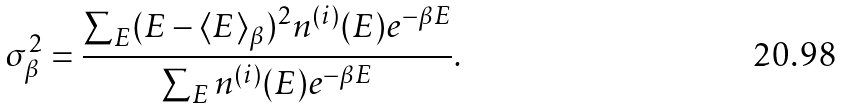<formula> <loc_0><loc_0><loc_500><loc_500>\sigma _ { \beta } ^ { 2 } = \frac { \sum _ { E } ( E - \langle E \rangle _ { \beta } ) ^ { 2 } n ^ { ( i ) } ( E ) e ^ { - \beta E } } { \sum _ { E } n ^ { ( i ) } ( E ) e ^ { - \beta E } } .</formula> 